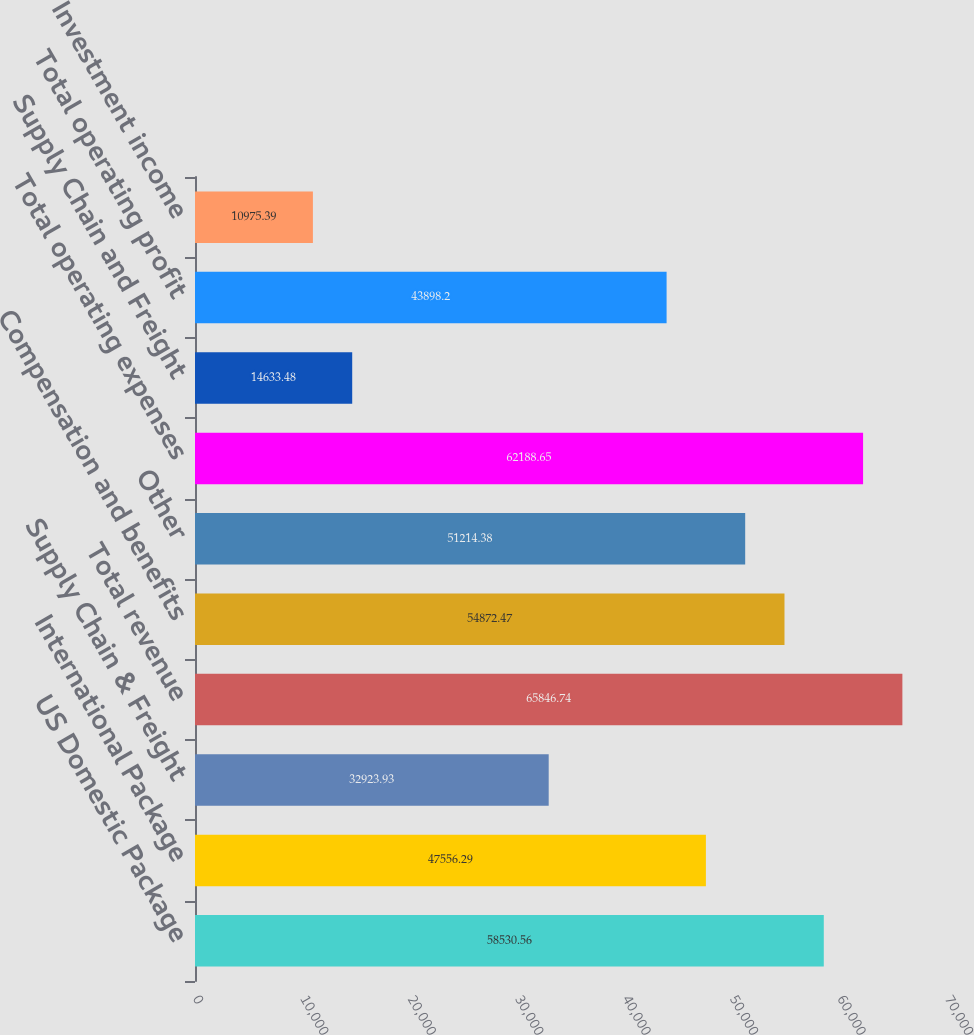Convert chart. <chart><loc_0><loc_0><loc_500><loc_500><bar_chart><fcel>US Domestic Package<fcel>International Package<fcel>Supply Chain & Freight<fcel>Total revenue<fcel>Compensation and benefits<fcel>Other<fcel>Total operating expenses<fcel>Supply Chain and Freight<fcel>Total operating profit<fcel>Investment income<nl><fcel>58530.6<fcel>47556.3<fcel>32923.9<fcel>65846.7<fcel>54872.5<fcel>51214.4<fcel>62188.7<fcel>14633.5<fcel>43898.2<fcel>10975.4<nl></chart> 